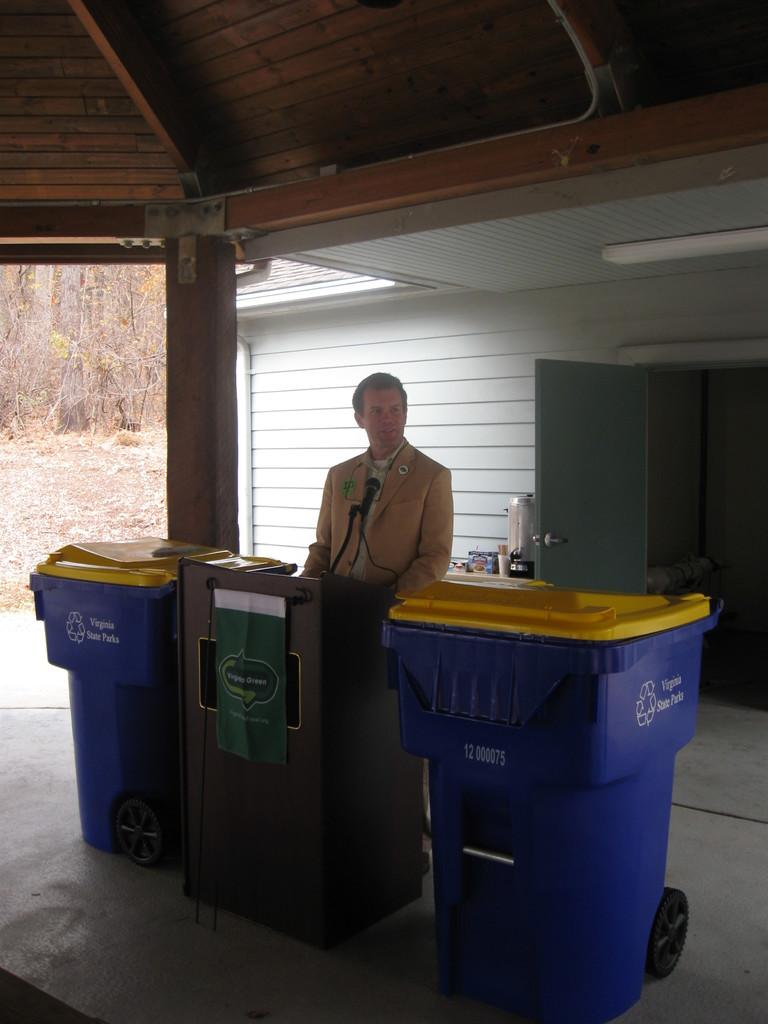<image>
Offer a succinct explanation of the picture presented. A man in a tan jacket is standing at a podium, with a banner that says Veggie Green draped in front of it, between two recycle cans. 